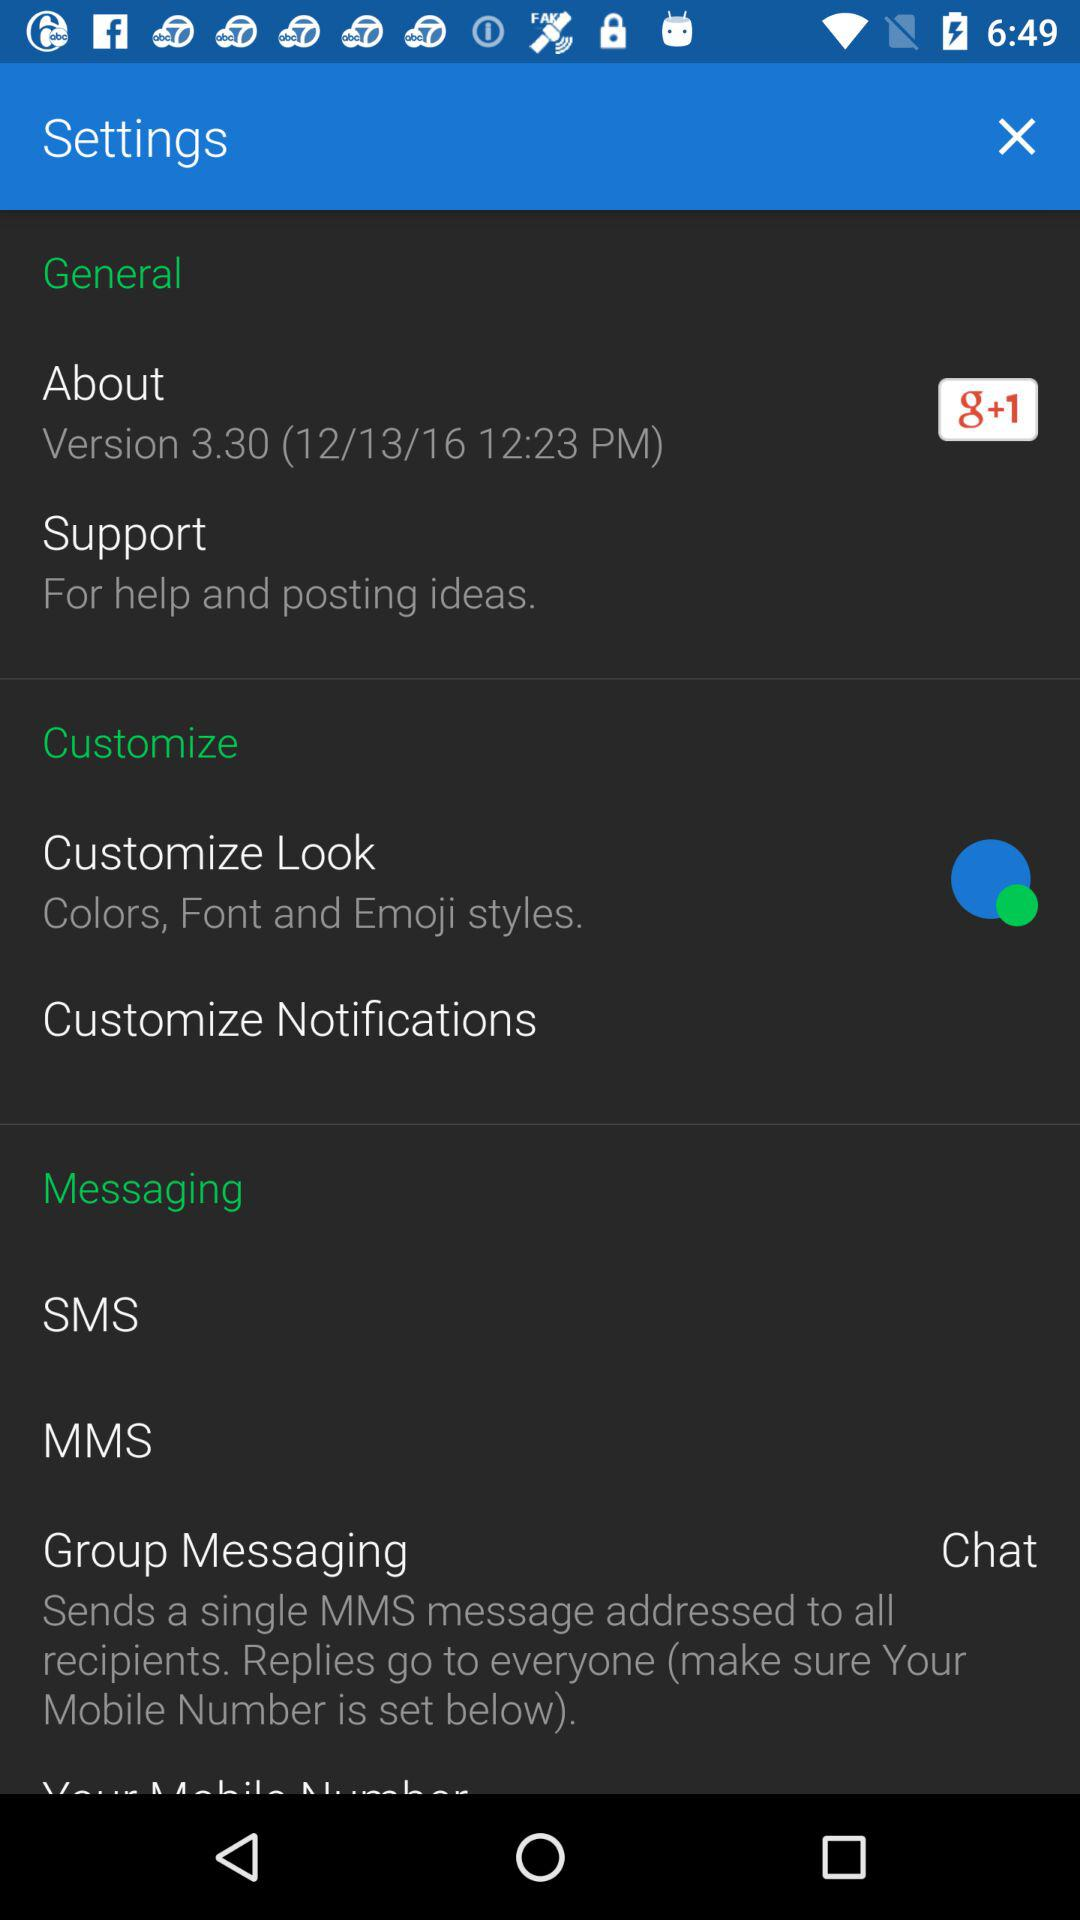What version of the application is being used? The used version is 3.30. 